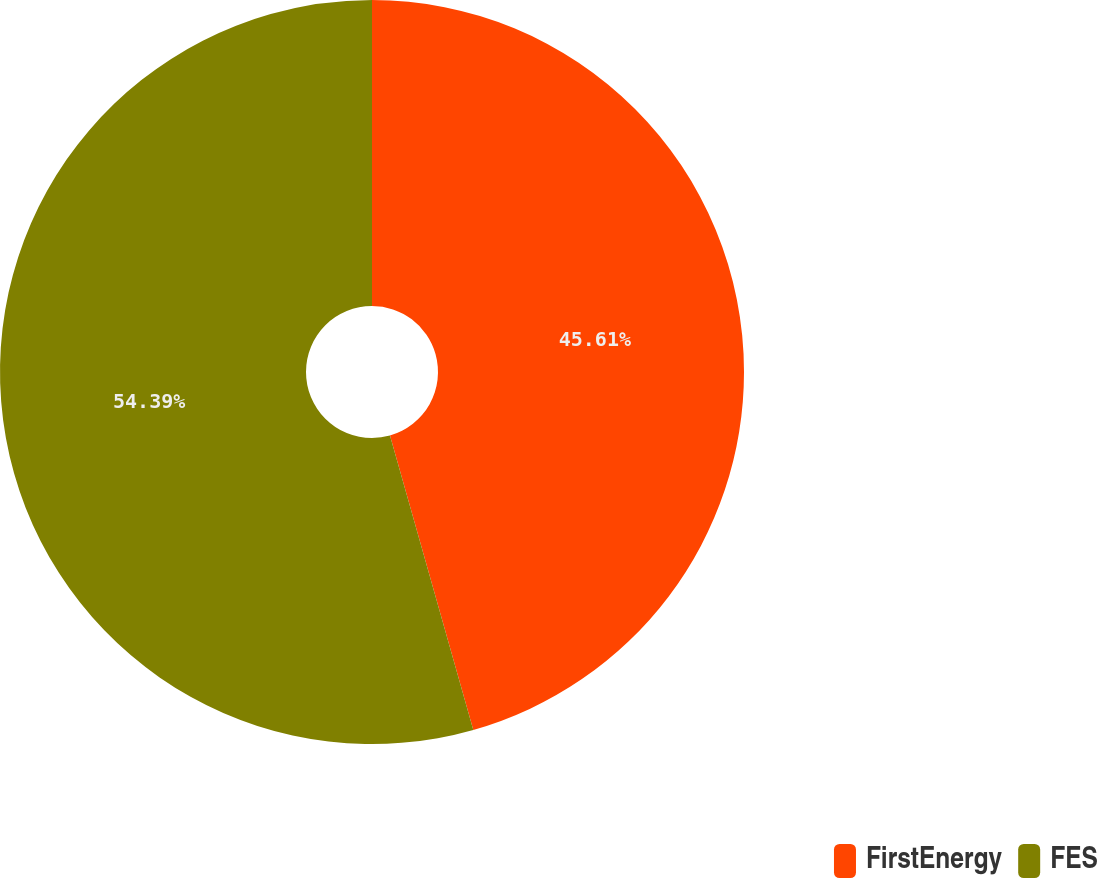Convert chart. <chart><loc_0><loc_0><loc_500><loc_500><pie_chart><fcel>FirstEnergy<fcel>FES<nl><fcel>45.61%<fcel>54.39%<nl></chart> 